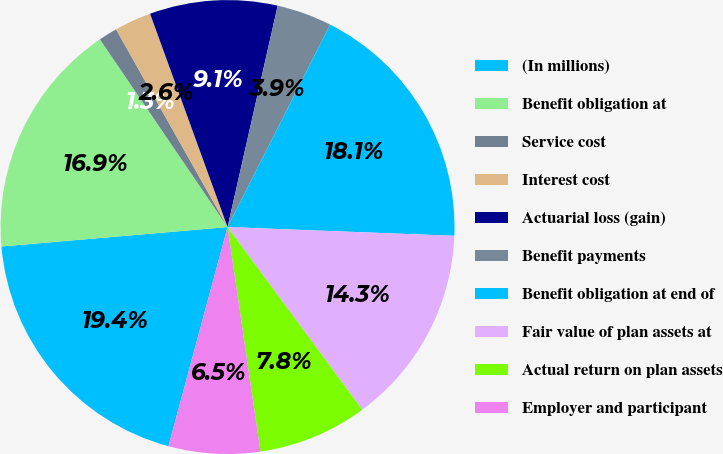Convert chart. <chart><loc_0><loc_0><loc_500><loc_500><pie_chart><fcel>(In millions)<fcel>Benefit obligation at<fcel>Service cost<fcel>Interest cost<fcel>Actuarial loss (gain)<fcel>Benefit payments<fcel>Benefit obligation at end of<fcel>Fair value of plan assets at<fcel>Actual return on plan assets<fcel>Employer and participant<nl><fcel>19.44%<fcel>16.86%<fcel>1.33%<fcel>2.63%<fcel>9.09%<fcel>3.92%<fcel>18.15%<fcel>14.27%<fcel>7.8%<fcel>6.51%<nl></chart> 